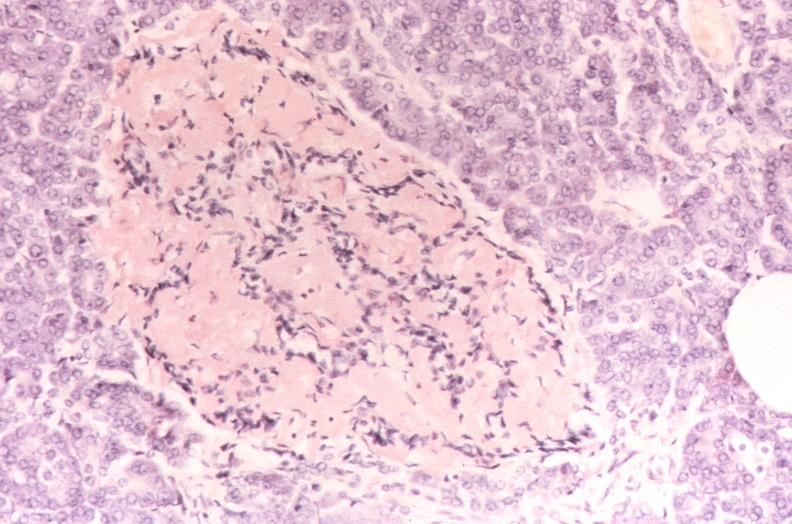what does this image show?
Answer the question using a single word or phrase. Pancreatic islet 